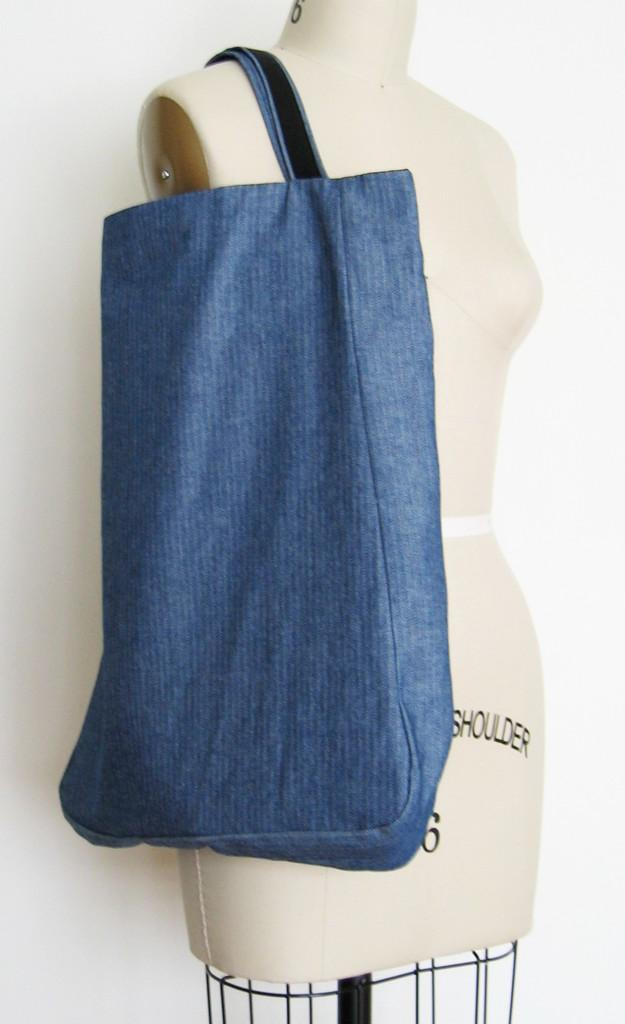What is the main subject in the image? There is a mannequin in the image. What other object can be seen in the image? There is a blue color bag in the image. What type of brass instrument is the mannequin playing in the image? There is no brass instrument or any musical instrument present in the image; it only features a mannequin and a blue color bag. 